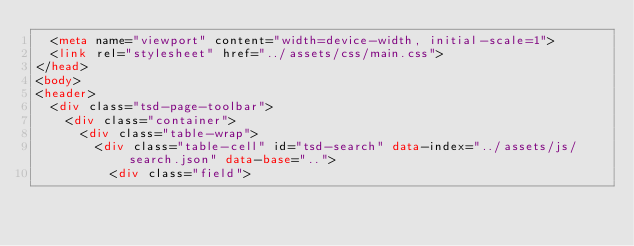<code> <loc_0><loc_0><loc_500><loc_500><_HTML_>	<meta name="viewport" content="width=device-width, initial-scale=1">
	<link rel="stylesheet" href="../assets/css/main.css">
</head>
<body>
<header>
	<div class="tsd-page-toolbar">
		<div class="container">
			<div class="table-wrap">
				<div class="table-cell" id="tsd-search" data-index="../assets/js/search.json" data-base="..">
					<div class="field"></code> 